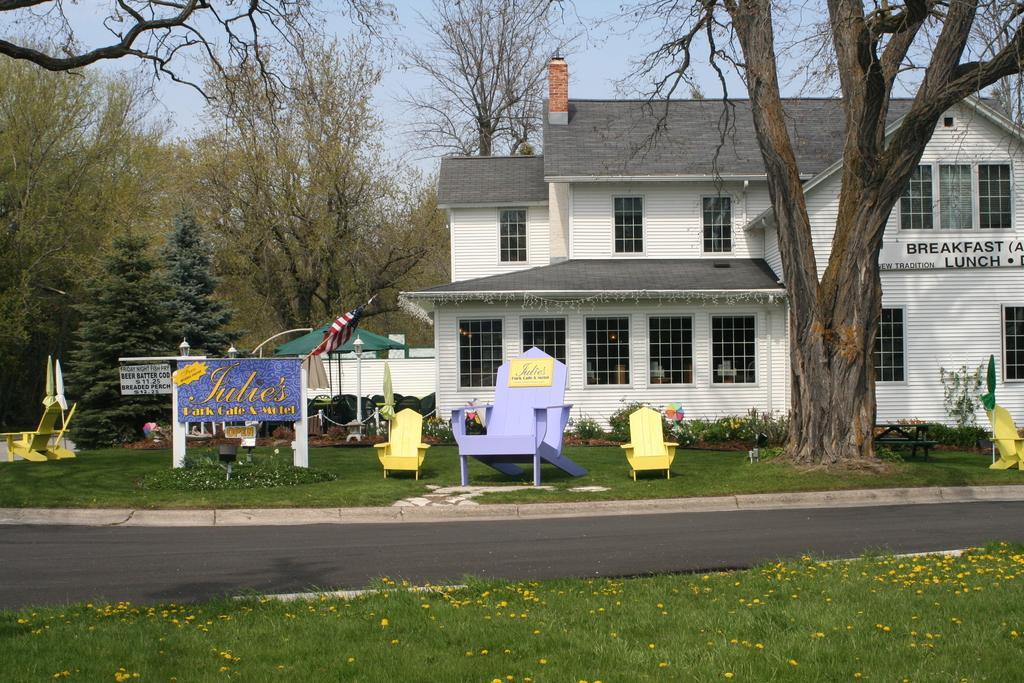Describe this image in one or two sentences. This image is taken outdoors. At the bottom of the image there is a ground with grass on it and there is a road. At the top of the image there is a sky. In the middle of the image there is a house with walls, windows, doors and a roof and there are many trees and a few plants. There are three empty chairs and a board with a text on it and there is a flag and a tent. 